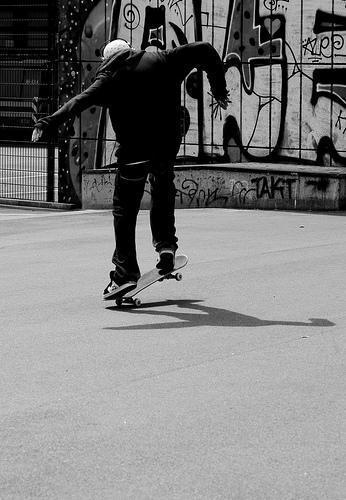How many men are in the photo?
Give a very brief answer. 1. 